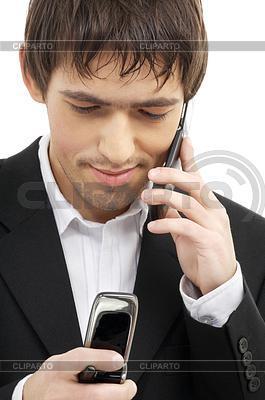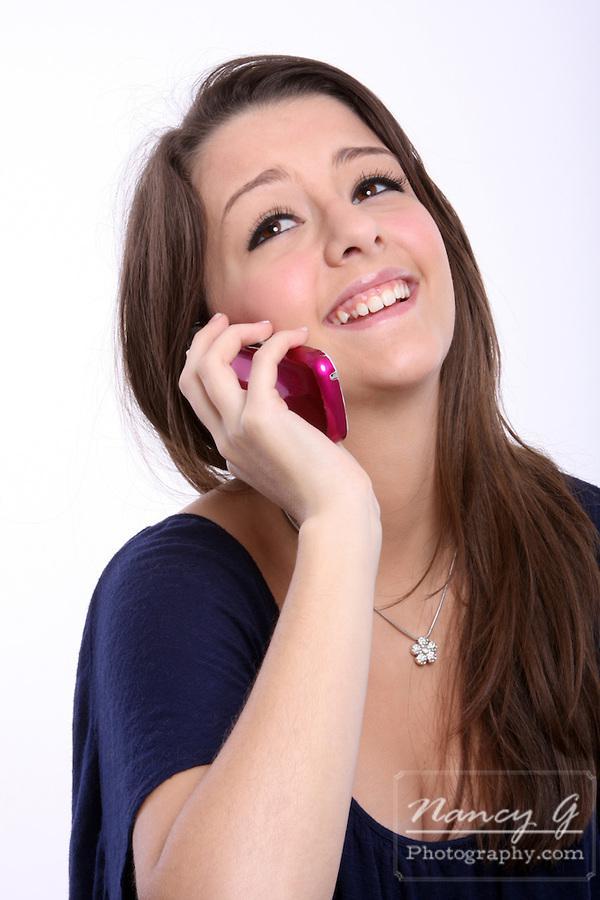The first image is the image on the left, the second image is the image on the right. Examine the images to the left and right. Is the description "There is exactly one person in every photo, and the person on the left is interacting with two phones at once, while the person on the right is showing an emotion and interacting with only one phone." accurate? Answer yes or no. Yes. The first image is the image on the left, the second image is the image on the right. Analyze the images presented: Is the assertion "One image shows a smiling woman holding a phone to her ear, and the other image features a man in a dark suit with something next to his ear and something held in front of him." valid? Answer yes or no. Yes. 